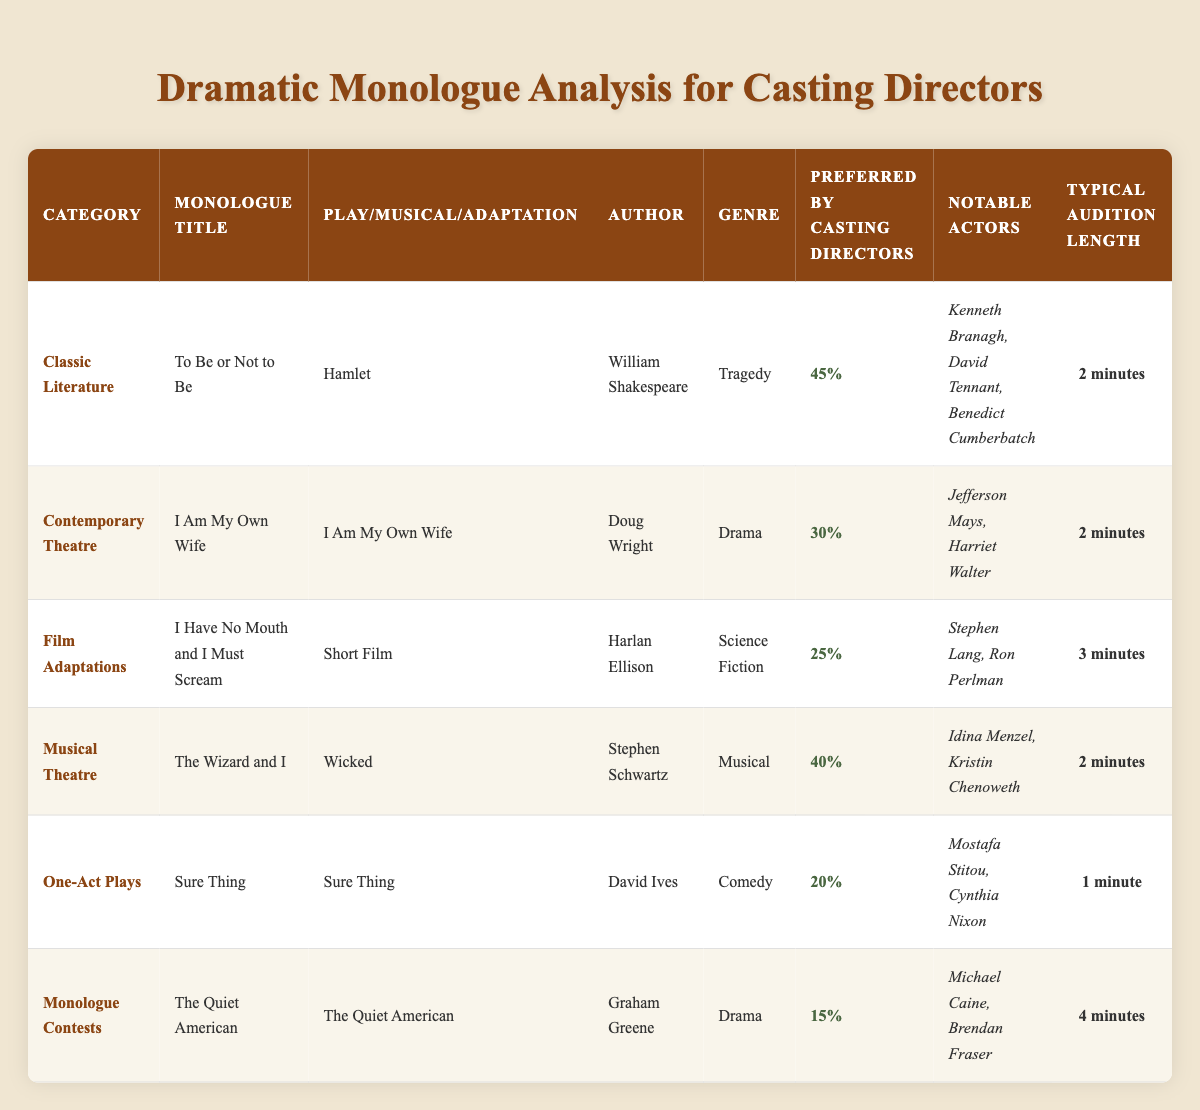What is the title of the monologue from "Hamlet"? The title of the monologue from "Hamlet" is "To Be or Not to Be."
Answer: To Be or Not to Be Which author wrote the monologue titled "The Quiet American"? The monologue titled "The Quiet American" was written by Graham Greene.
Answer: Graham Greene What genre does the monologue "I Have No Mouth and I Must Scream" belong to? "I Have No Mouth and I Must Scream" belongs to the genre of Science Fiction.
Answer: Science Fiction What is the typical audition length for the monologue titled "Sure Thing"? The typical audition length for "Sure Thing" is 1 minute.
Answer: 1 minute Which dramatic monologue has the highest percentage preferred by casting directors? The dramatic monologue with the highest percentage preferred by casting directors is "To Be or Not to Be" at 45%.
Answer: 45% How many notable actors are listed for the monologue "I Am My Own Wife"? There are two notable actors listed for "I Am My Own Wife": Jefferson Mays and Harriet Walter.
Answer: 2 What is the difference in preferred percentages between the "Classic Literature" and the "Monologue Contests" categories? The preferred percentage for "Classic Literature" is 45% and for "Monologue Contests" it is 15%. The difference is 45% - 15% = 30%.
Answer: 30% What is the average typical audition length for the monologues listed in the table? The typical audition lengths are 2, 2, 3, 2, 1, and 4 minutes. The sum of these lengths is 14 minutes. There are 6 monologues, so the average is 14/6 = 2.33 minutes.
Answer: 2.33 minutes Which category has the monologue with the longest typical audition length? The "Monologue Contests" category has the longest typical audition length at 4 minutes.
Answer: Monologue Contests In which category do the notable actors Idina Menzel and Kristin Chenoweth appear? Idina Menzel and Kristin Chenoweth appear in the "Musical Theatre" category.
Answer: Musical Theatre Which genre has the lowest percentage of preference among casting directors? The genre with the lowest percentage of preference among casting directors is Comedy, with the monologue "Sure Thing" at 20%.
Answer: Comedy 